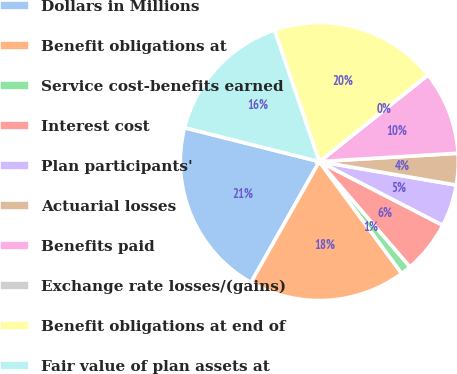<chart> <loc_0><loc_0><loc_500><loc_500><pie_chart><fcel>Dollars in Millions<fcel>Benefit obligations at<fcel>Service cost-benefits earned<fcel>Interest cost<fcel>Plan participants'<fcel>Actuarial losses<fcel>Benefits paid<fcel>Exchange rate losses/(gains)<fcel>Benefit obligations at end of<fcel>Fair value of plan assets at<nl><fcel>20.73%<fcel>18.29%<fcel>1.22%<fcel>6.1%<fcel>4.88%<fcel>3.66%<fcel>9.76%<fcel>0.01%<fcel>19.51%<fcel>15.85%<nl></chart> 